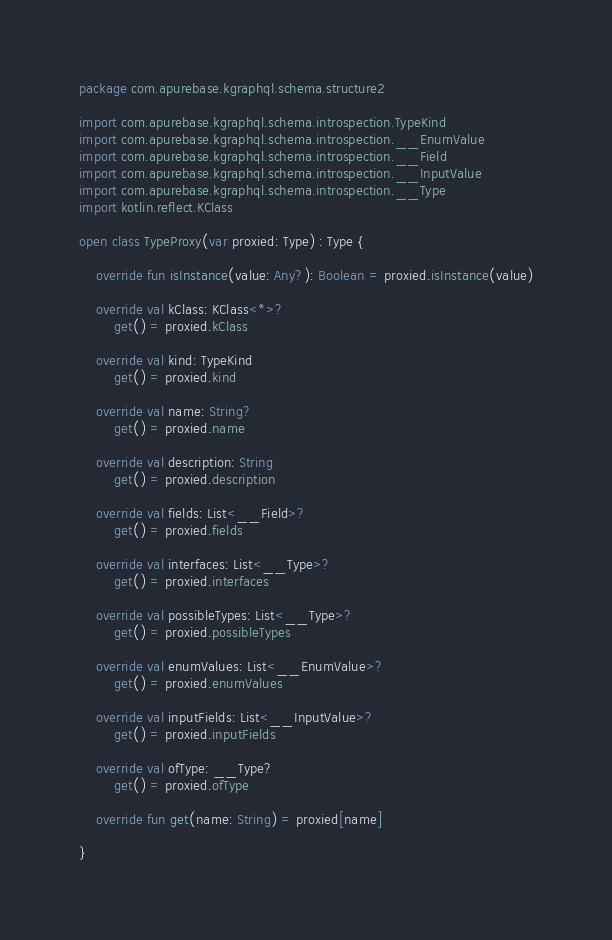Convert code to text. <code><loc_0><loc_0><loc_500><loc_500><_Kotlin_>package com.apurebase.kgraphql.schema.structure2

import com.apurebase.kgraphql.schema.introspection.TypeKind
import com.apurebase.kgraphql.schema.introspection.__EnumValue
import com.apurebase.kgraphql.schema.introspection.__Field
import com.apurebase.kgraphql.schema.introspection.__InputValue
import com.apurebase.kgraphql.schema.introspection.__Type
import kotlin.reflect.KClass

open class TypeProxy(var proxied: Type) : Type {

    override fun isInstance(value: Any?): Boolean = proxied.isInstance(value)

    override val kClass: KClass<*>?
        get() = proxied.kClass

    override val kind: TypeKind
        get() = proxied.kind

    override val name: String?
        get() = proxied.name

    override val description: String
        get() = proxied.description

    override val fields: List<__Field>?
        get() = proxied.fields

    override val interfaces: List<__Type>?
        get() = proxied.interfaces

    override val possibleTypes: List<__Type>?
        get() = proxied.possibleTypes

    override val enumValues: List<__EnumValue>?
        get() = proxied.enumValues

    override val inputFields: List<__InputValue>?
        get() = proxied.inputFields

    override val ofType: __Type?
        get() = proxied.ofType

    override fun get(name: String) = proxied[name]

}</code> 